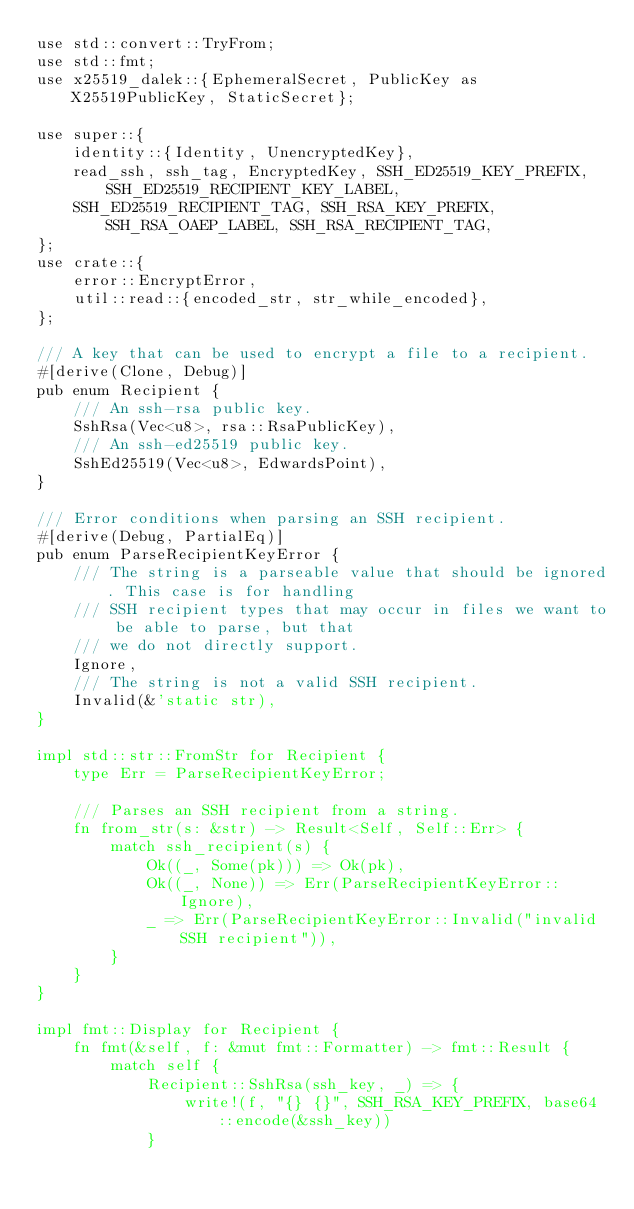Convert code to text. <code><loc_0><loc_0><loc_500><loc_500><_Rust_>use std::convert::TryFrom;
use std::fmt;
use x25519_dalek::{EphemeralSecret, PublicKey as X25519PublicKey, StaticSecret};

use super::{
    identity::{Identity, UnencryptedKey},
    read_ssh, ssh_tag, EncryptedKey, SSH_ED25519_KEY_PREFIX, SSH_ED25519_RECIPIENT_KEY_LABEL,
    SSH_ED25519_RECIPIENT_TAG, SSH_RSA_KEY_PREFIX, SSH_RSA_OAEP_LABEL, SSH_RSA_RECIPIENT_TAG,
};
use crate::{
    error::EncryptError,
    util::read::{encoded_str, str_while_encoded},
};

/// A key that can be used to encrypt a file to a recipient.
#[derive(Clone, Debug)]
pub enum Recipient {
    /// An ssh-rsa public key.
    SshRsa(Vec<u8>, rsa::RsaPublicKey),
    /// An ssh-ed25519 public key.
    SshEd25519(Vec<u8>, EdwardsPoint),
}

/// Error conditions when parsing an SSH recipient.
#[derive(Debug, PartialEq)]
pub enum ParseRecipientKeyError {
    /// The string is a parseable value that should be ignored. This case is for handling
    /// SSH recipient types that may occur in files we want to be able to parse, but that
    /// we do not directly support.
    Ignore,
    /// The string is not a valid SSH recipient.
    Invalid(&'static str),
}

impl std::str::FromStr for Recipient {
    type Err = ParseRecipientKeyError;

    /// Parses an SSH recipient from a string.
    fn from_str(s: &str) -> Result<Self, Self::Err> {
        match ssh_recipient(s) {
            Ok((_, Some(pk))) => Ok(pk),
            Ok((_, None)) => Err(ParseRecipientKeyError::Ignore),
            _ => Err(ParseRecipientKeyError::Invalid("invalid SSH recipient")),
        }
    }
}

impl fmt::Display for Recipient {
    fn fmt(&self, f: &mut fmt::Formatter) -> fmt::Result {
        match self {
            Recipient::SshRsa(ssh_key, _) => {
                write!(f, "{} {}", SSH_RSA_KEY_PREFIX, base64::encode(&ssh_key))
            }</code> 